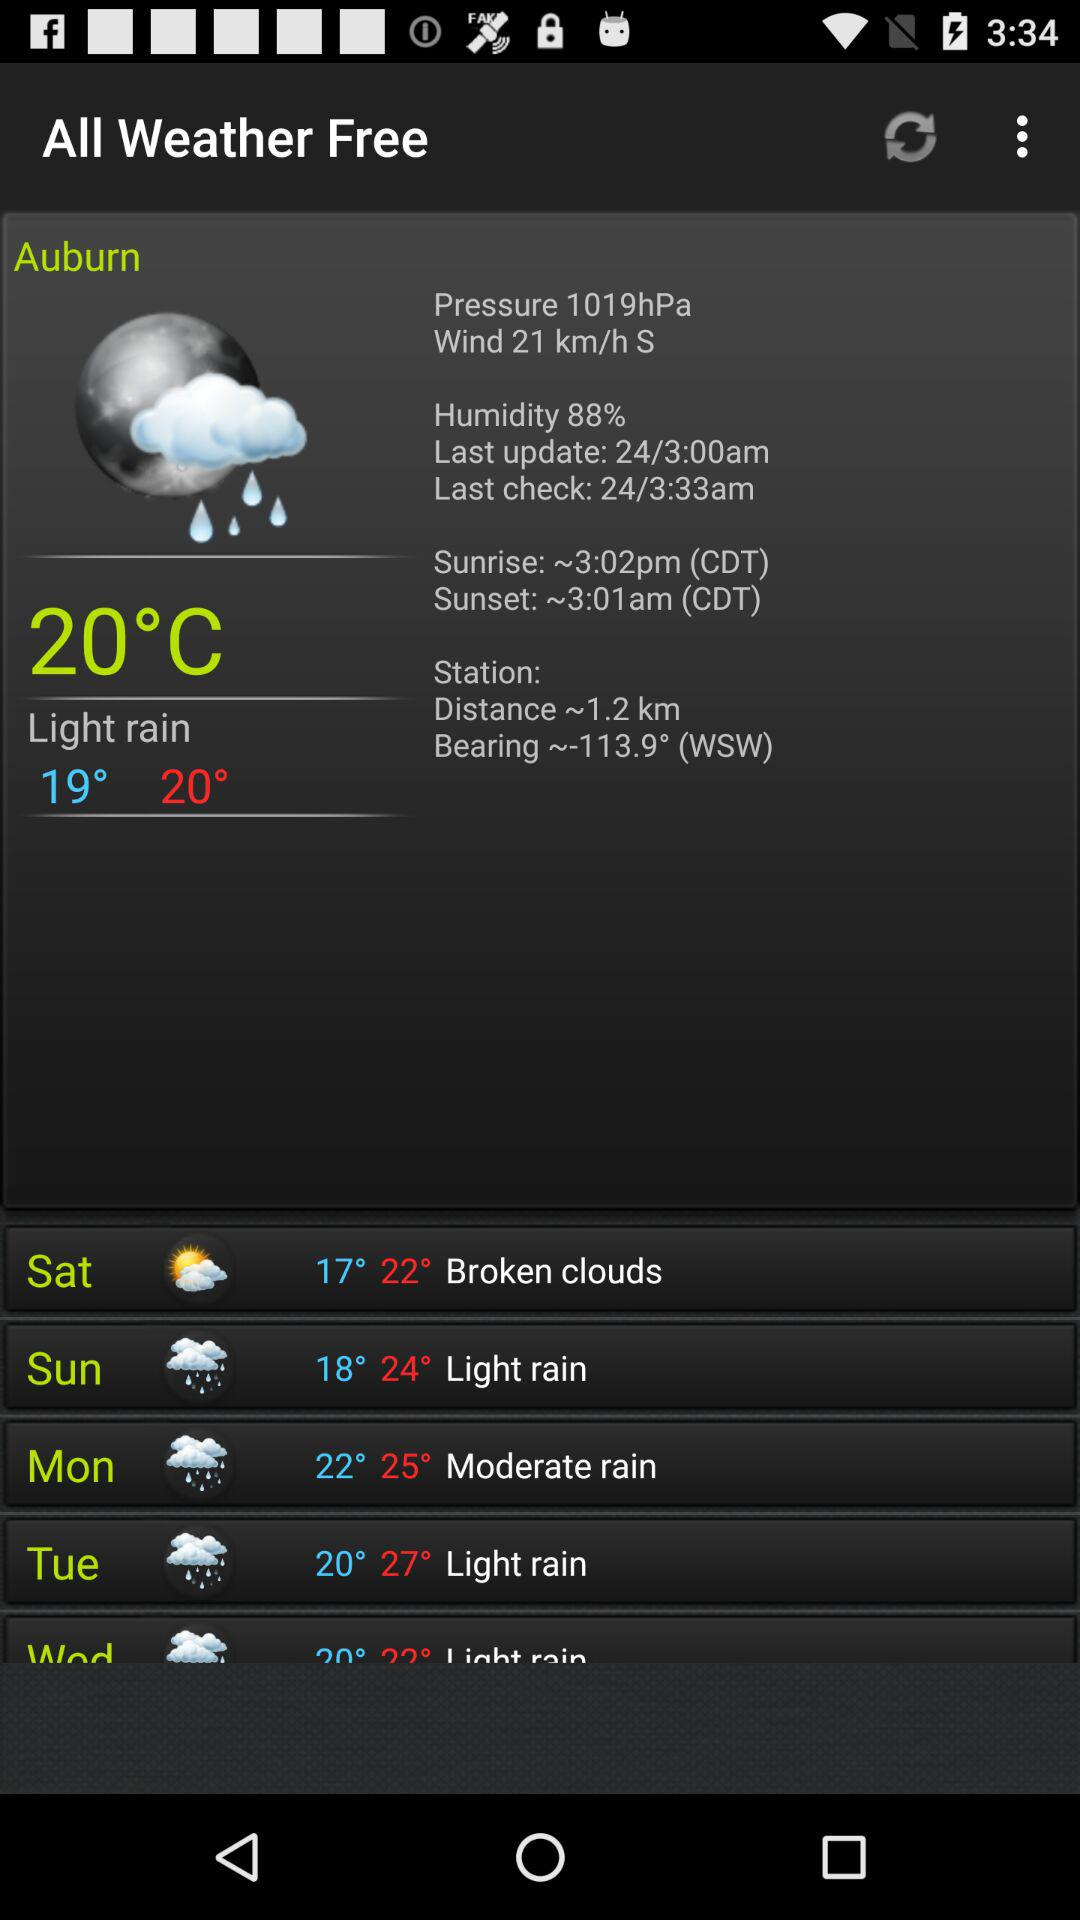What is the sunset time? The sunset time is 3:01am (CDT). 